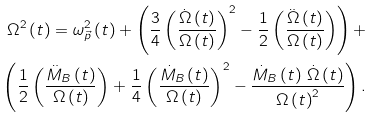Convert formula to latex. <formula><loc_0><loc_0><loc_500><loc_500>\Omega ^ { 2 } \left ( t \right ) = \omega _ { \vec { p } } ^ { 2 } \left ( t \right ) + \left ( \frac { 3 } { 4 } \left ( \frac { \dot { \Omega } \left ( t \right ) } { \Omega \left ( t \right ) } \right ) ^ { 2 } - \frac { 1 } { 2 } \left ( \frac { \ddot { \Omega } \left ( t \right ) } { \Omega \left ( t \right ) } \right ) \right ) + \\ \left ( \frac { 1 } { 2 } \left ( \frac { \ddot { M } _ { B } \left ( t \right ) } { \Omega \left ( t \right ) } \right ) + \frac { 1 } { 4 } \left ( \frac { \dot { M } _ { B } \left ( t \right ) } { \Omega \left ( t \right ) } \right ) ^ { 2 } - \frac { \dot { M } _ { B } \left ( t \right ) \, \dot { \Omega } \left ( t \right ) } { \Omega \left ( t \right ) ^ { 2 } } \right ) .</formula> 